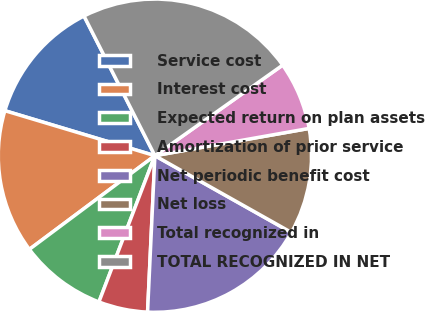<chart> <loc_0><loc_0><loc_500><loc_500><pie_chart><fcel>Service cost<fcel>Interest cost<fcel>Expected return on plan assets<fcel>Amortization of prior service<fcel>Net periodic benefit cost<fcel>Net loss<fcel>Total recognized in<fcel>TOTAL RECOGNIZED IN NET<nl><fcel>12.89%<fcel>14.84%<fcel>8.98%<fcel>5.07%<fcel>17.59%<fcel>10.94%<fcel>7.03%<fcel>22.66%<nl></chart> 